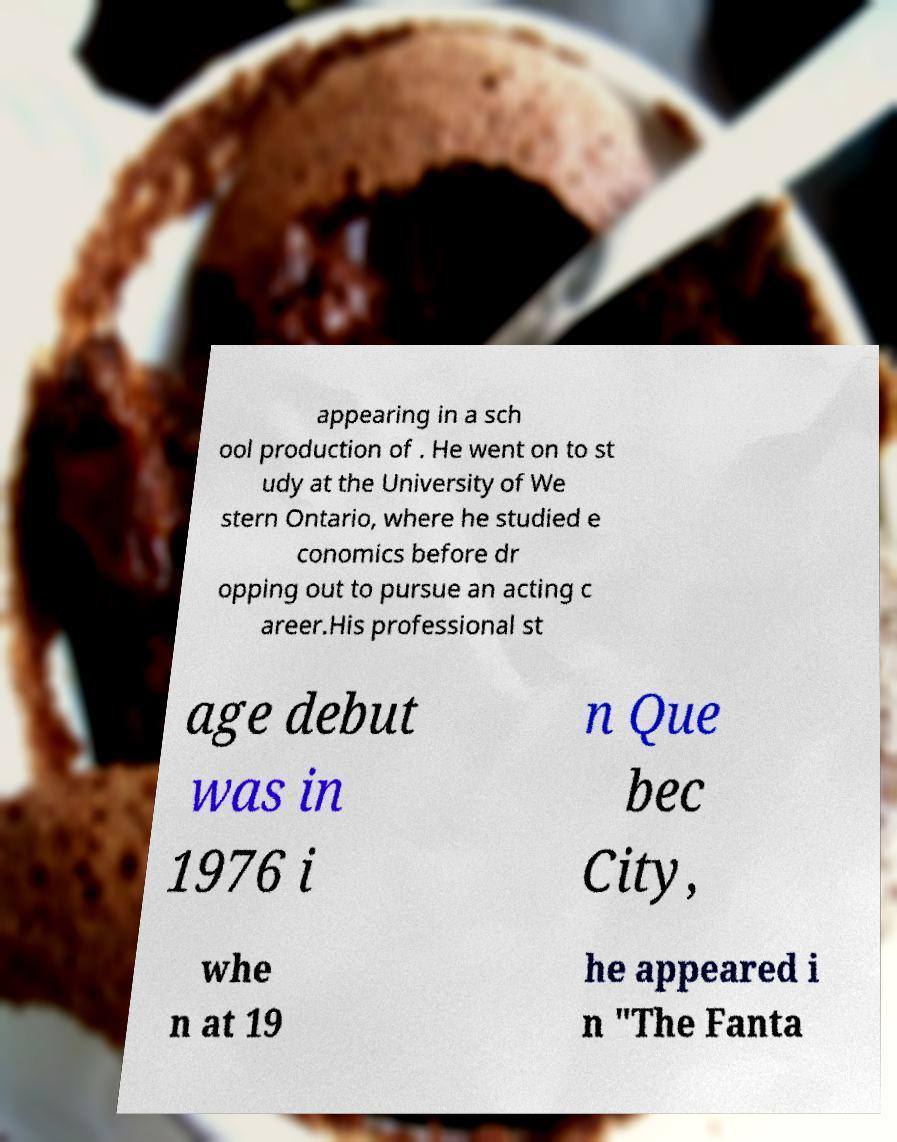Can you accurately transcribe the text from the provided image for me? appearing in a sch ool production of . He went on to st udy at the University of We stern Ontario, where he studied e conomics before dr opping out to pursue an acting c areer.His professional st age debut was in 1976 i n Que bec City, whe n at 19 he appeared i n "The Fanta 